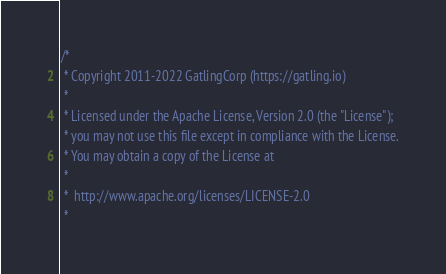Convert code to text. <code><loc_0><loc_0><loc_500><loc_500><_Scala_>/*
 * Copyright 2011-2022 GatlingCorp (https://gatling.io)
 *
 * Licensed under the Apache License, Version 2.0 (the "License");
 * you may not use this file except in compliance with the License.
 * You may obtain a copy of the License at
 *
 *  http://www.apache.org/licenses/LICENSE-2.0
 *</code> 